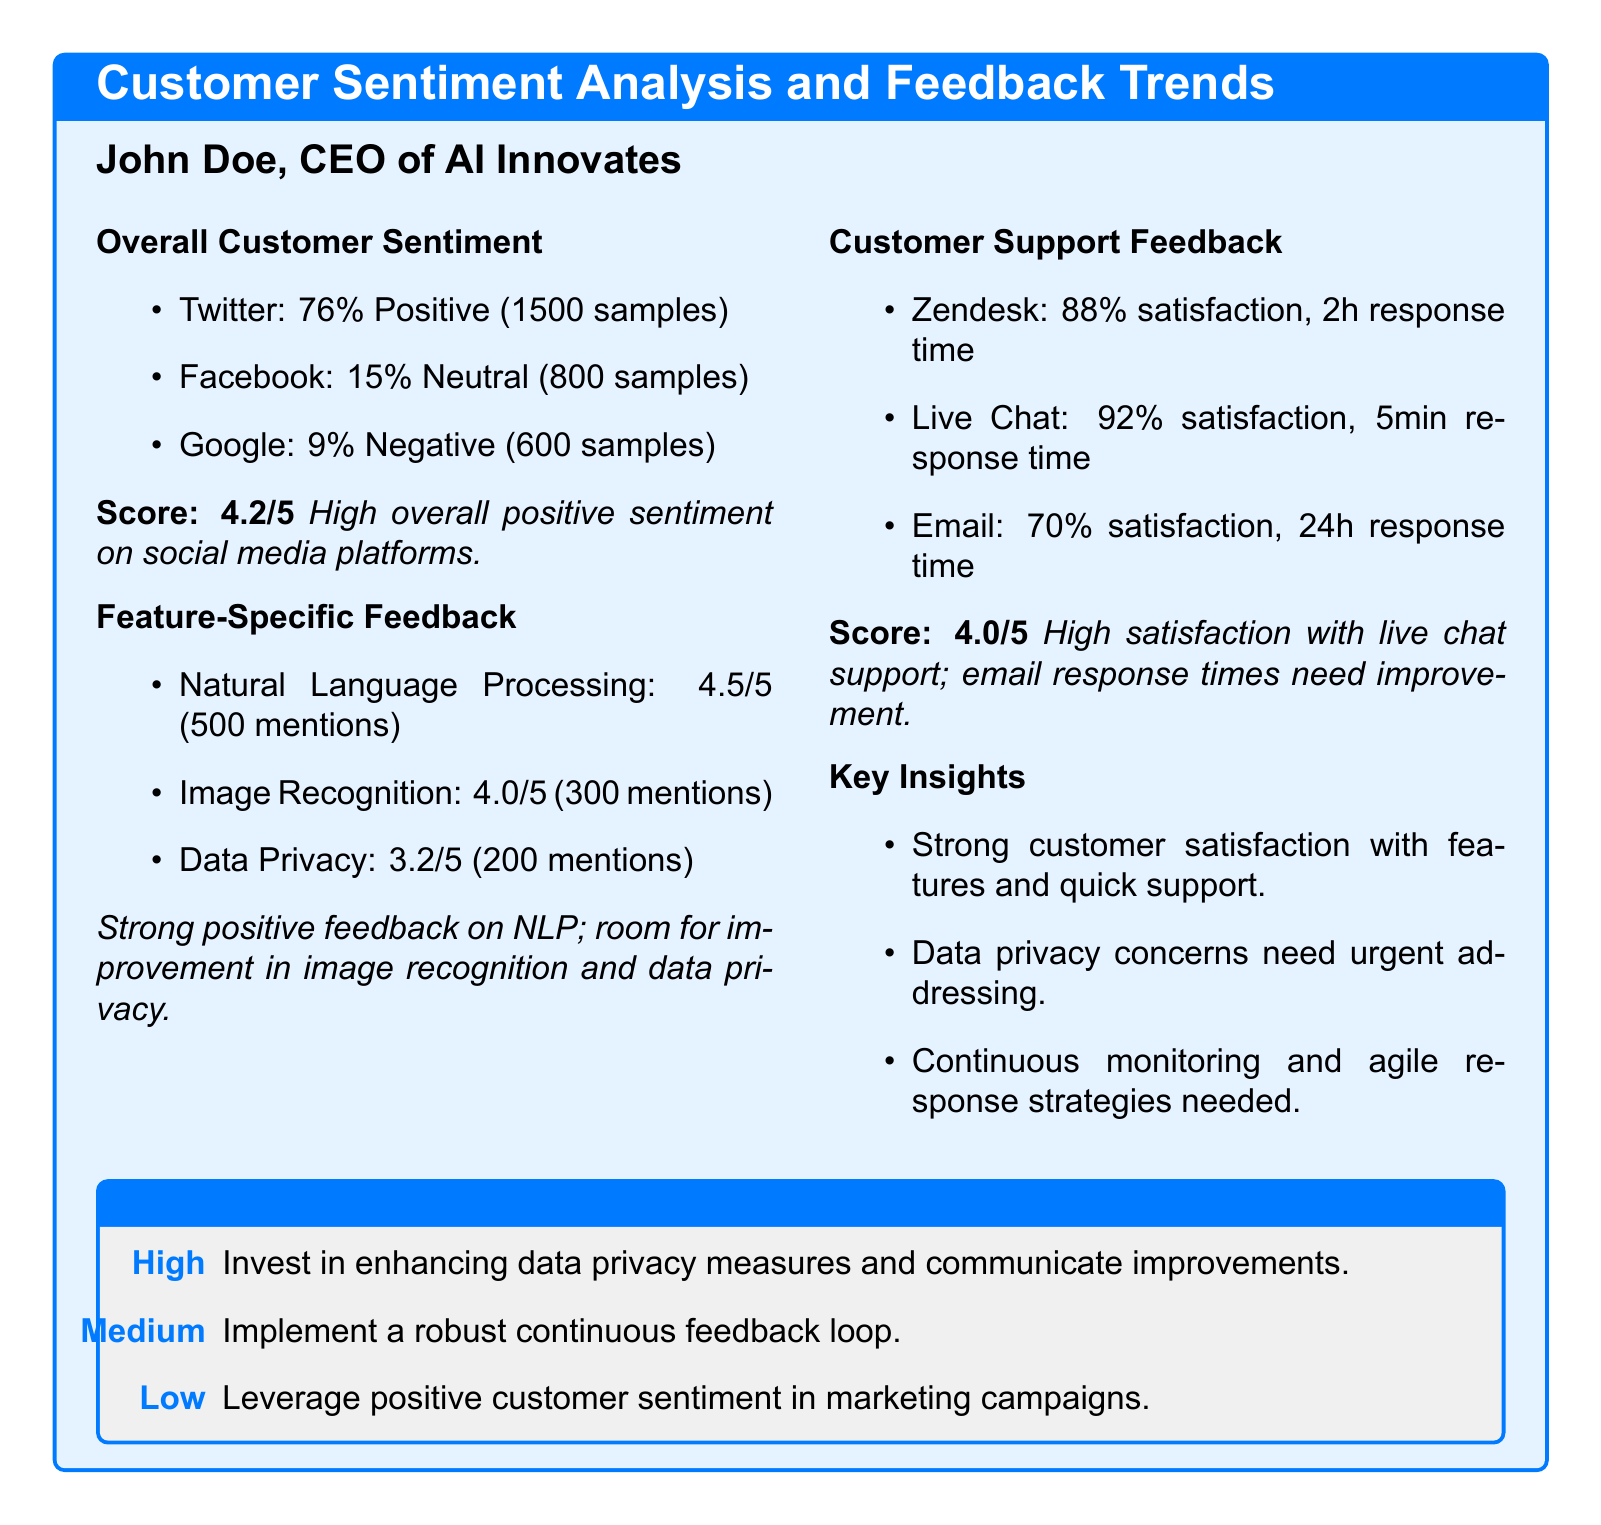What is the overall customer sentiment score? The overall customer sentiment score is provided in the document as a numerical rating based on customer feedback.
Answer: 4.2/5 What percentage of Twitter feedback is positive? The document lists the percentages of positive, neutral, and negative feedback from various platforms, specifically mentioning Twitter.
Answer: 76% Which feature received the highest rating? The feature-specific feedback section provides ratings, and the highest rating listed is for Natural Language Processing.
Answer: Natural Language Processing What is the satisfaction rate for live chat support? Customer support feedback includes satisfaction rates for different support channels, showing that live chat has a high rating.
Answer: 92% What concern needs urgent addressing according to the insights? The key insights summarize current issues, specifically mentioning a particular concern that customers have raised.
Answer: Data privacy What is the response time for email support? The customer support feedback section specifies the response times for various support channels, including email.
Answer: 24h What category is recommended to invest in for high priority? The recommendations section classifies suggested actions into three priority levels, detailing which area should receive high investment.
Answer: Data privacy measures How many samples were used to assess customer sentiment on Facebook? The overall customer sentiment section specifies the number of samples for each platform, including Facebook.
Answer: 800 samples What is the score for customer support overall? The document includes an overall score for customer support based on customer feedback ratings.
Answer: 4.0/5 